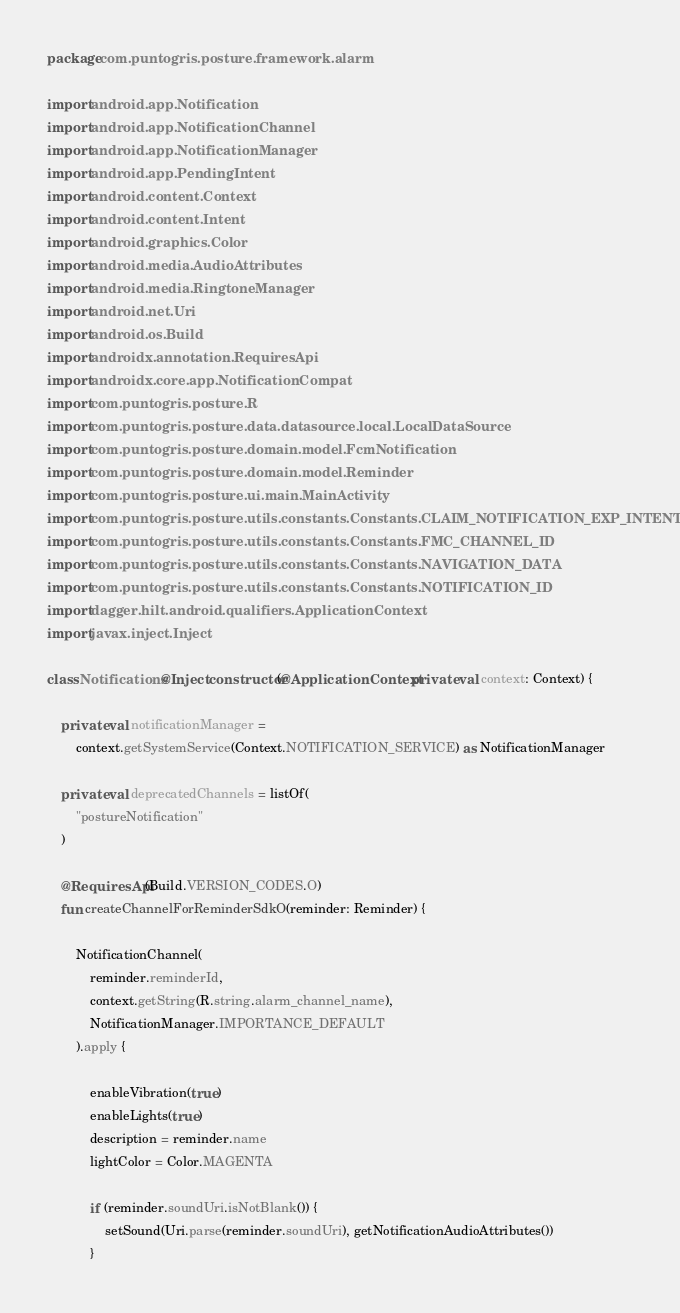Convert code to text. <code><loc_0><loc_0><loc_500><loc_500><_Kotlin_>package com.puntogris.posture.framework.alarm

import android.app.Notification
import android.app.NotificationChannel
import android.app.NotificationManager
import android.app.PendingIntent
import android.content.Context
import android.content.Intent
import android.graphics.Color
import android.media.AudioAttributes
import android.media.RingtoneManager
import android.net.Uri
import android.os.Build
import androidx.annotation.RequiresApi
import androidx.core.app.NotificationCompat
import com.puntogris.posture.R
import com.puntogris.posture.data.datasource.local.LocalDataSource
import com.puntogris.posture.domain.model.FcmNotification
import com.puntogris.posture.domain.model.Reminder
import com.puntogris.posture.ui.main.MainActivity
import com.puntogris.posture.utils.constants.Constants.CLAIM_NOTIFICATION_EXP_INTENT
import com.puntogris.posture.utils.constants.Constants.FMC_CHANNEL_ID
import com.puntogris.posture.utils.constants.Constants.NAVIGATION_DATA
import com.puntogris.posture.utils.constants.Constants.NOTIFICATION_ID
import dagger.hilt.android.qualifiers.ApplicationContext
import javax.inject.Inject

class Notifications @Inject constructor(@ApplicationContext private val context: Context) {

    private val notificationManager =
        context.getSystemService(Context.NOTIFICATION_SERVICE) as NotificationManager

    private val deprecatedChannels = listOf(
        "postureNotification"
    )

    @RequiresApi(Build.VERSION_CODES.O)
    fun createChannelForReminderSdkO(reminder: Reminder) {

        NotificationChannel(
            reminder.reminderId,
            context.getString(R.string.alarm_channel_name),
            NotificationManager.IMPORTANCE_DEFAULT
        ).apply {

            enableVibration(true)
            enableLights(true)
            description = reminder.name
            lightColor = Color.MAGENTA

            if (reminder.soundUri.isNotBlank()) {
                setSound(Uri.parse(reminder.soundUri), getNotificationAudioAttributes())
            }</code> 